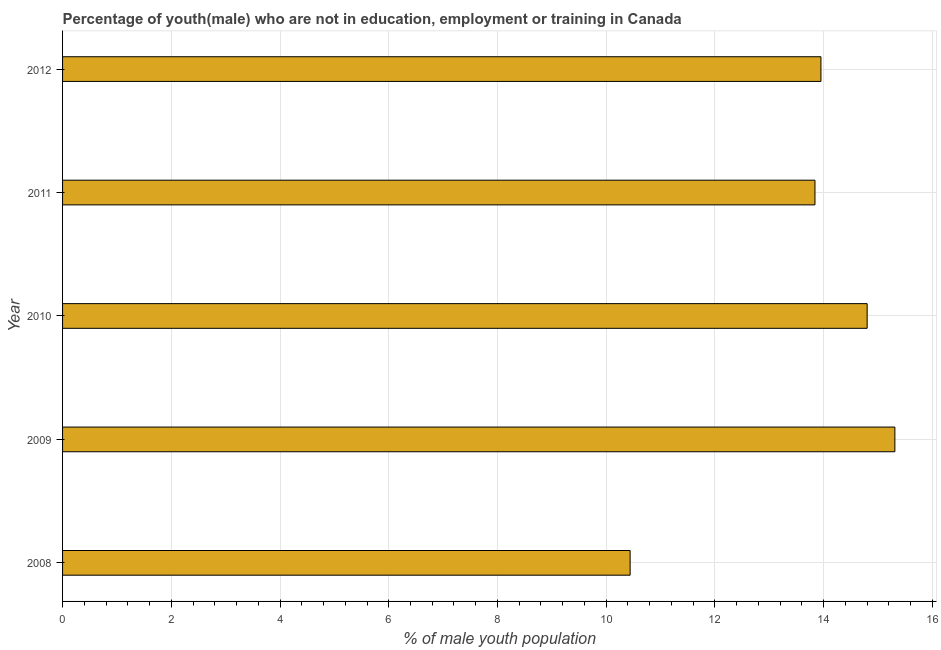Does the graph contain grids?
Offer a terse response. Yes. What is the title of the graph?
Ensure brevity in your answer.  Percentage of youth(male) who are not in education, employment or training in Canada. What is the label or title of the X-axis?
Your response must be concise. % of male youth population. What is the unemployed male youth population in 2008?
Provide a succinct answer. 10.44. Across all years, what is the maximum unemployed male youth population?
Offer a terse response. 15.31. Across all years, what is the minimum unemployed male youth population?
Make the answer very short. 10.44. In which year was the unemployed male youth population maximum?
Your response must be concise. 2009. In which year was the unemployed male youth population minimum?
Ensure brevity in your answer.  2008. What is the sum of the unemployed male youth population?
Offer a very short reply. 68.34. What is the difference between the unemployed male youth population in 2011 and 2012?
Offer a very short reply. -0.11. What is the average unemployed male youth population per year?
Provide a short and direct response. 13.67. What is the median unemployed male youth population?
Ensure brevity in your answer.  13.95. In how many years, is the unemployed male youth population greater than 7.2 %?
Ensure brevity in your answer.  5. Do a majority of the years between 2011 and 2010 (inclusive) have unemployed male youth population greater than 9.2 %?
Your response must be concise. No. What is the ratio of the unemployed male youth population in 2008 to that in 2012?
Ensure brevity in your answer.  0.75. Is the unemployed male youth population in 2008 less than that in 2009?
Your answer should be very brief. Yes. Is the difference between the unemployed male youth population in 2008 and 2009 greater than the difference between any two years?
Offer a terse response. Yes. What is the difference between the highest and the second highest unemployed male youth population?
Offer a terse response. 0.51. What is the difference between the highest and the lowest unemployed male youth population?
Offer a terse response. 4.87. What is the difference between two consecutive major ticks on the X-axis?
Your answer should be very brief. 2. Are the values on the major ticks of X-axis written in scientific E-notation?
Offer a terse response. No. What is the % of male youth population of 2008?
Ensure brevity in your answer.  10.44. What is the % of male youth population in 2009?
Your answer should be compact. 15.31. What is the % of male youth population in 2010?
Your answer should be compact. 14.8. What is the % of male youth population of 2011?
Provide a short and direct response. 13.84. What is the % of male youth population in 2012?
Keep it short and to the point. 13.95. What is the difference between the % of male youth population in 2008 and 2009?
Provide a succinct answer. -4.87. What is the difference between the % of male youth population in 2008 and 2010?
Ensure brevity in your answer.  -4.36. What is the difference between the % of male youth population in 2008 and 2012?
Give a very brief answer. -3.51. What is the difference between the % of male youth population in 2009 and 2010?
Keep it short and to the point. 0.51. What is the difference between the % of male youth population in 2009 and 2011?
Offer a very short reply. 1.47. What is the difference between the % of male youth population in 2009 and 2012?
Ensure brevity in your answer.  1.36. What is the difference between the % of male youth population in 2010 and 2012?
Provide a succinct answer. 0.85. What is the difference between the % of male youth population in 2011 and 2012?
Your answer should be very brief. -0.11. What is the ratio of the % of male youth population in 2008 to that in 2009?
Provide a succinct answer. 0.68. What is the ratio of the % of male youth population in 2008 to that in 2010?
Make the answer very short. 0.7. What is the ratio of the % of male youth population in 2008 to that in 2011?
Give a very brief answer. 0.75. What is the ratio of the % of male youth population in 2008 to that in 2012?
Ensure brevity in your answer.  0.75. What is the ratio of the % of male youth population in 2009 to that in 2010?
Offer a terse response. 1.03. What is the ratio of the % of male youth population in 2009 to that in 2011?
Make the answer very short. 1.11. What is the ratio of the % of male youth population in 2009 to that in 2012?
Give a very brief answer. 1.1. What is the ratio of the % of male youth population in 2010 to that in 2011?
Your response must be concise. 1.07. What is the ratio of the % of male youth population in 2010 to that in 2012?
Provide a short and direct response. 1.06. What is the ratio of the % of male youth population in 2011 to that in 2012?
Your answer should be very brief. 0.99. 